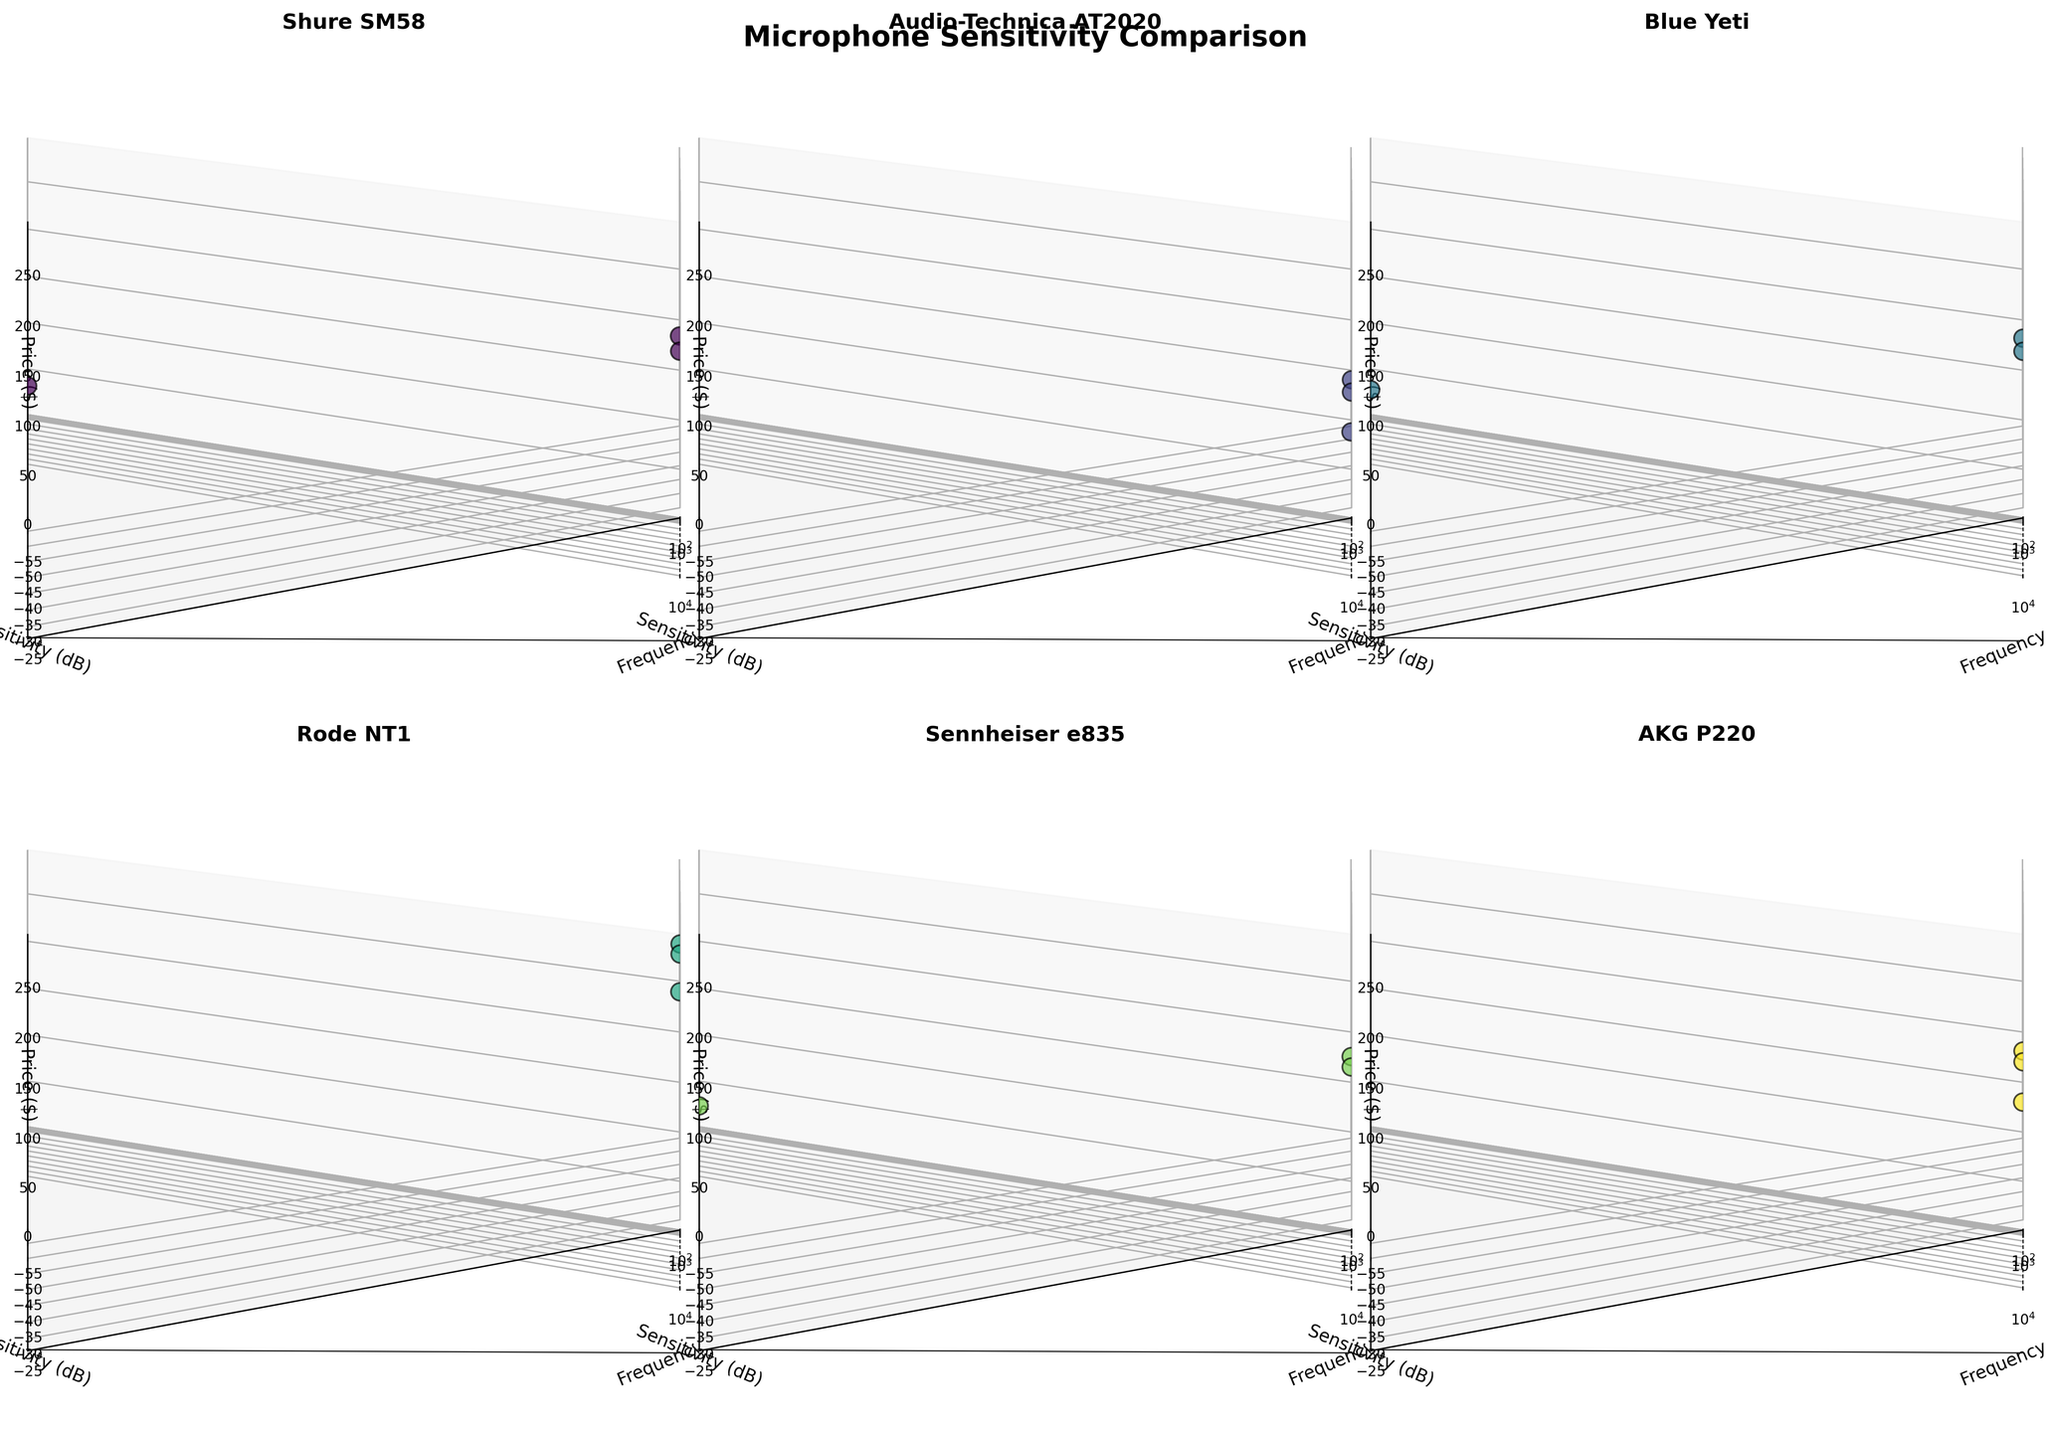What's the title of the figure? The title of the figure is placed at the top and generally indicates what the entire set of plots is about.
Answer: Microphone Sensitivity Comparison Which microphone model has the lowest sensitivity at 1000 Hz? Sensitivity at 1000 Hz for each microphone model is plotted on the y-axis. Identify each model's data point at the 1000 Hz mark and compare their sensitivity values. Sennheiser e835 has the lowest value at 1000 Hz.
Answer: Sennheiser e835 What is the price range for the microphones compared? Check the z-axis limits and the data points in the subplots to find the lowest and highest price values. The lowest value is 99, and the highest is 269.
Answer: $99 to $269 How does the sensitivity of Rode NT1 at 1000 Hz compare to that of Blue Yeti at 100 Hz? Look at the subplot for Rode NT1 and note its sensitivity at 1000 Hz. Then compare it with the sensitivity value for Blue Yeti at 100 Hz in its respective subplot.
Answer: Rode NT1 is more sensitive Which model has the highest sensitivity at high frequencies (10000 Hz)? Look at the y-values for the data points at 10000 Hz in each subplot. The highest sensitivity at 10000 Hz is observed in Rode NT1.
Answer: Rode NT1 What is the average price of the microphones displayed? To find the average price, add the prices for all models and divide by the number of models.
Answer: $140.67 Between Shure SM58 and AKG P220, which model is more sensitive across all frequencies? Compare the sensitivity values at each frequency (100 Hz, 1000 Hz, 10000 Hz) between Shure SM58 and AKG P220. AKG P220 has higher sensitivity for all frequencies.
Answer: AKG P220 Which model's data points show the widest range of sensitivity values across the frequencies? Examine the range from the minimum to maximum sensitivity values for each model by looking at their respective subplots. The widest range is for Shure SM58.
Answer: Shure SM58 